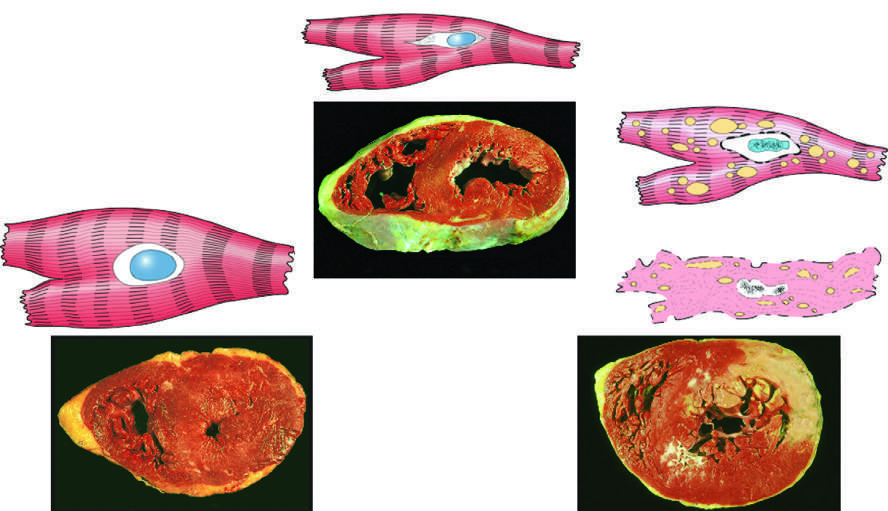what is the irreversible injury?
Answer the question using a single word or phrase. Ischemic coagulative necrosis 